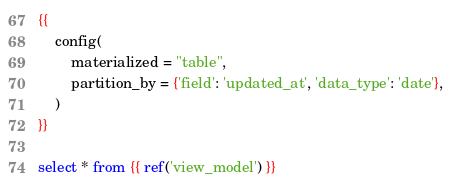Convert code to text. <code><loc_0><loc_0><loc_500><loc_500><_SQL_>
{{
	config(
		materialized = "table",
		partition_by = {'field': 'updated_at', 'data_type': 'date'},
	)
}}

select * from {{ ref('view_model') }}
</code> 